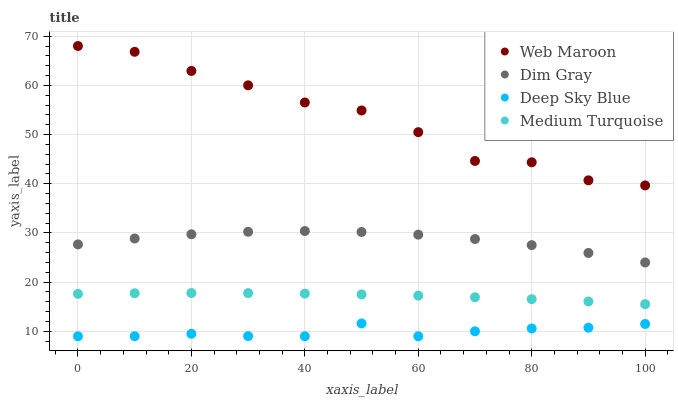Does Deep Sky Blue have the minimum area under the curve?
Answer yes or no. Yes. Does Web Maroon have the maximum area under the curve?
Answer yes or no. Yes. Does Medium Turquoise have the minimum area under the curve?
Answer yes or no. No. Does Medium Turquoise have the maximum area under the curve?
Answer yes or no. No. Is Medium Turquoise the smoothest?
Answer yes or no. Yes. Is Web Maroon the roughest?
Answer yes or no. Yes. Is Web Maroon the smoothest?
Answer yes or no. No. Is Medium Turquoise the roughest?
Answer yes or no. No. Does Deep Sky Blue have the lowest value?
Answer yes or no. Yes. Does Medium Turquoise have the lowest value?
Answer yes or no. No. Does Web Maroon have the highest value?
Answer yes or no. Yes. Does Medium Turquoise have the highest value?
Answer yes or no. No. Is Deep Sky Blue less than Dim Gray?
Answer yes or no. Yes. Is Web Maroon greater than Deep Sky Blue?
Answer yes or no. Yes. Does Deep Sky Blue intersect Dim Gray?
Answer yes or no. No. 